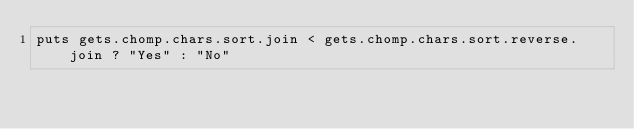<code> <loc_0><loc_0><loc_500><loc_500><_Ruby_>puts gets.chomp.chars.sort.join < gets.chomp.chars.sort.reverse.join ? "Yes" : "No"</code> 